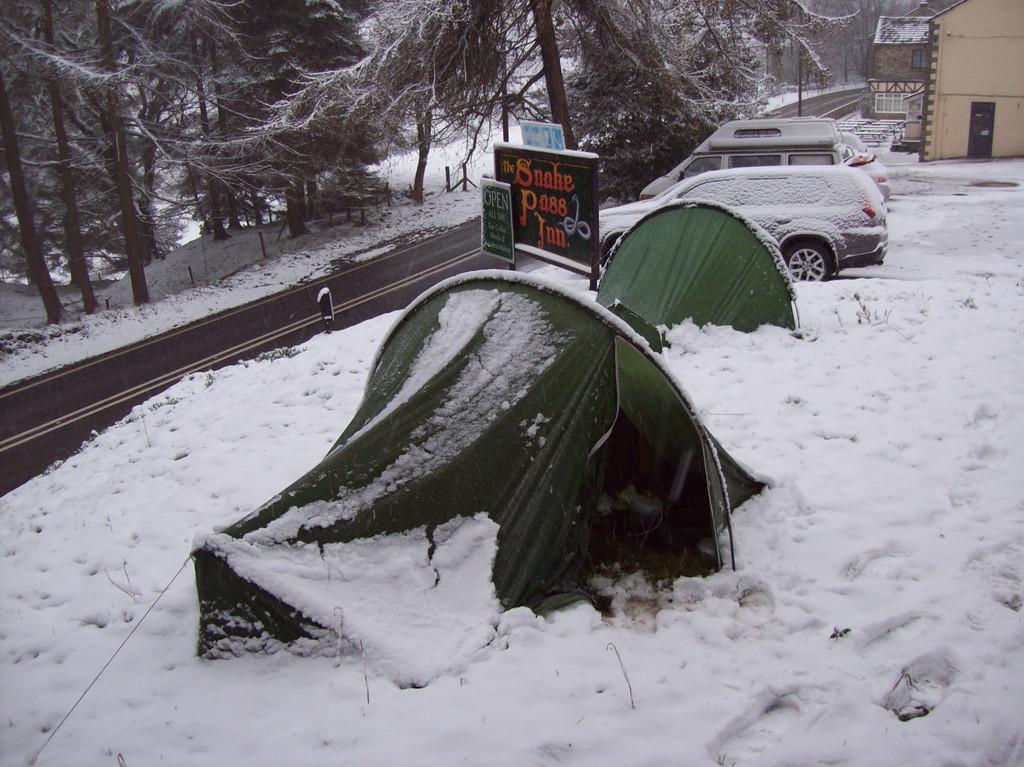What is the name of the inn?
Your answer should be very brief. The snake pass inn. 